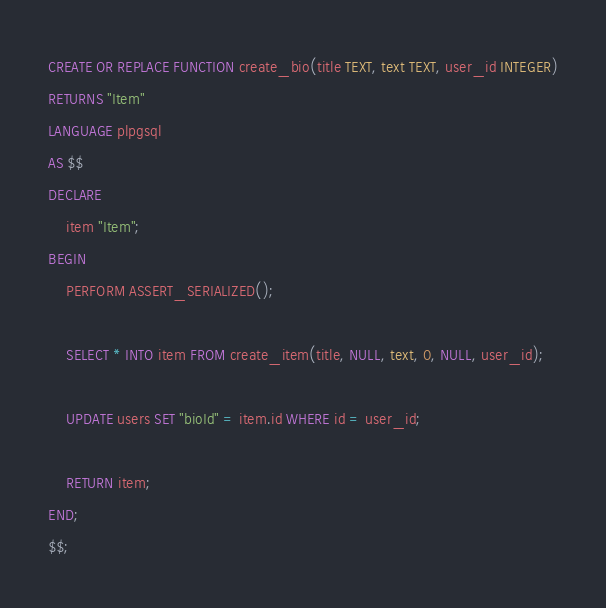Convert code to text. <code><loc_0><loc_0><loc_500><loc_500><_SQL_>CREATE OR REPLACE FUNCTION create_bio(title TEXT, text TEXT, user_id INTEGER)
RETURNS "Item"
LANGUAGE plpgsql
AS $$
DECLARE
    item "Item";
BEGIN
    PERFORM ASSERT_SERIALIZED();

    SELECT * INTO item FROM create_item(title, NULL, text, 0, NULL, user_id);

    UPDATE users SET "bioId" = item.id WHERE id = user_id;

    RETURN item;
END;
$$;</code> 